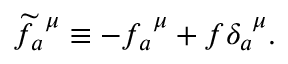Convert formula to latex. <formula><loc_0><loc_0><loc_500><loc_500>\widetilde { f } _ { a } ^ { \mu } \equiv - f _ { a } ^ { \mu } + f \delta _ { a } ^ { \mu } .</formula> 